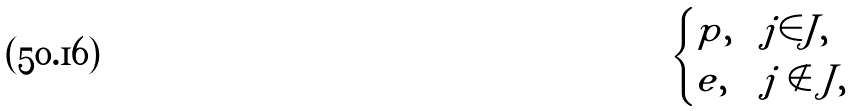Convert formula to latex. <formula><loc_0><loc_0><loc_500><loc_500>\begin{cases} p , & j \in J , \\ e , & j \notin J , \end{cases}</formula> 